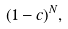Convert formula to latex. <formula><loc_0><loc_0><loc_500><loc_500>( 1 - c ) ^ { N } ,</formula> 